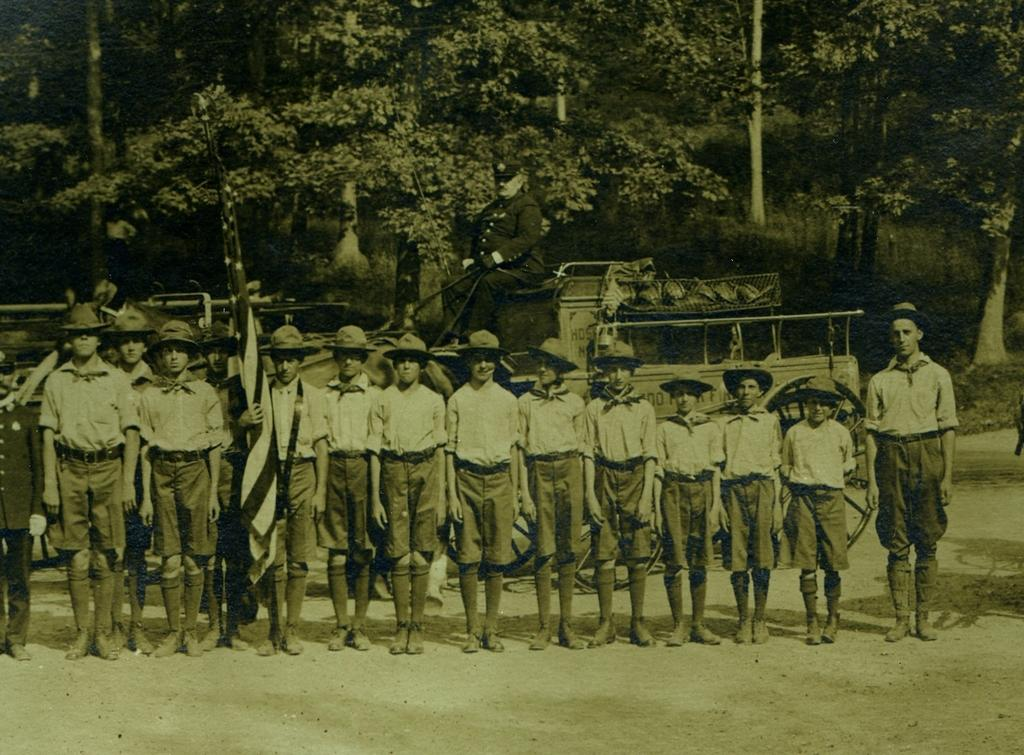How many people are in the image? There is a group of people in the image, but the exact number is not specified. What is one person in the group holding? One person is holding a flag. What can be seen in the background of the image? There are vehicles and trees with green color in the background of the image. What type of sock is hanging on the tree in the image? There is no sock present in the image; it features a group of people, a flag, vehicles, and trees with green color in the background. 